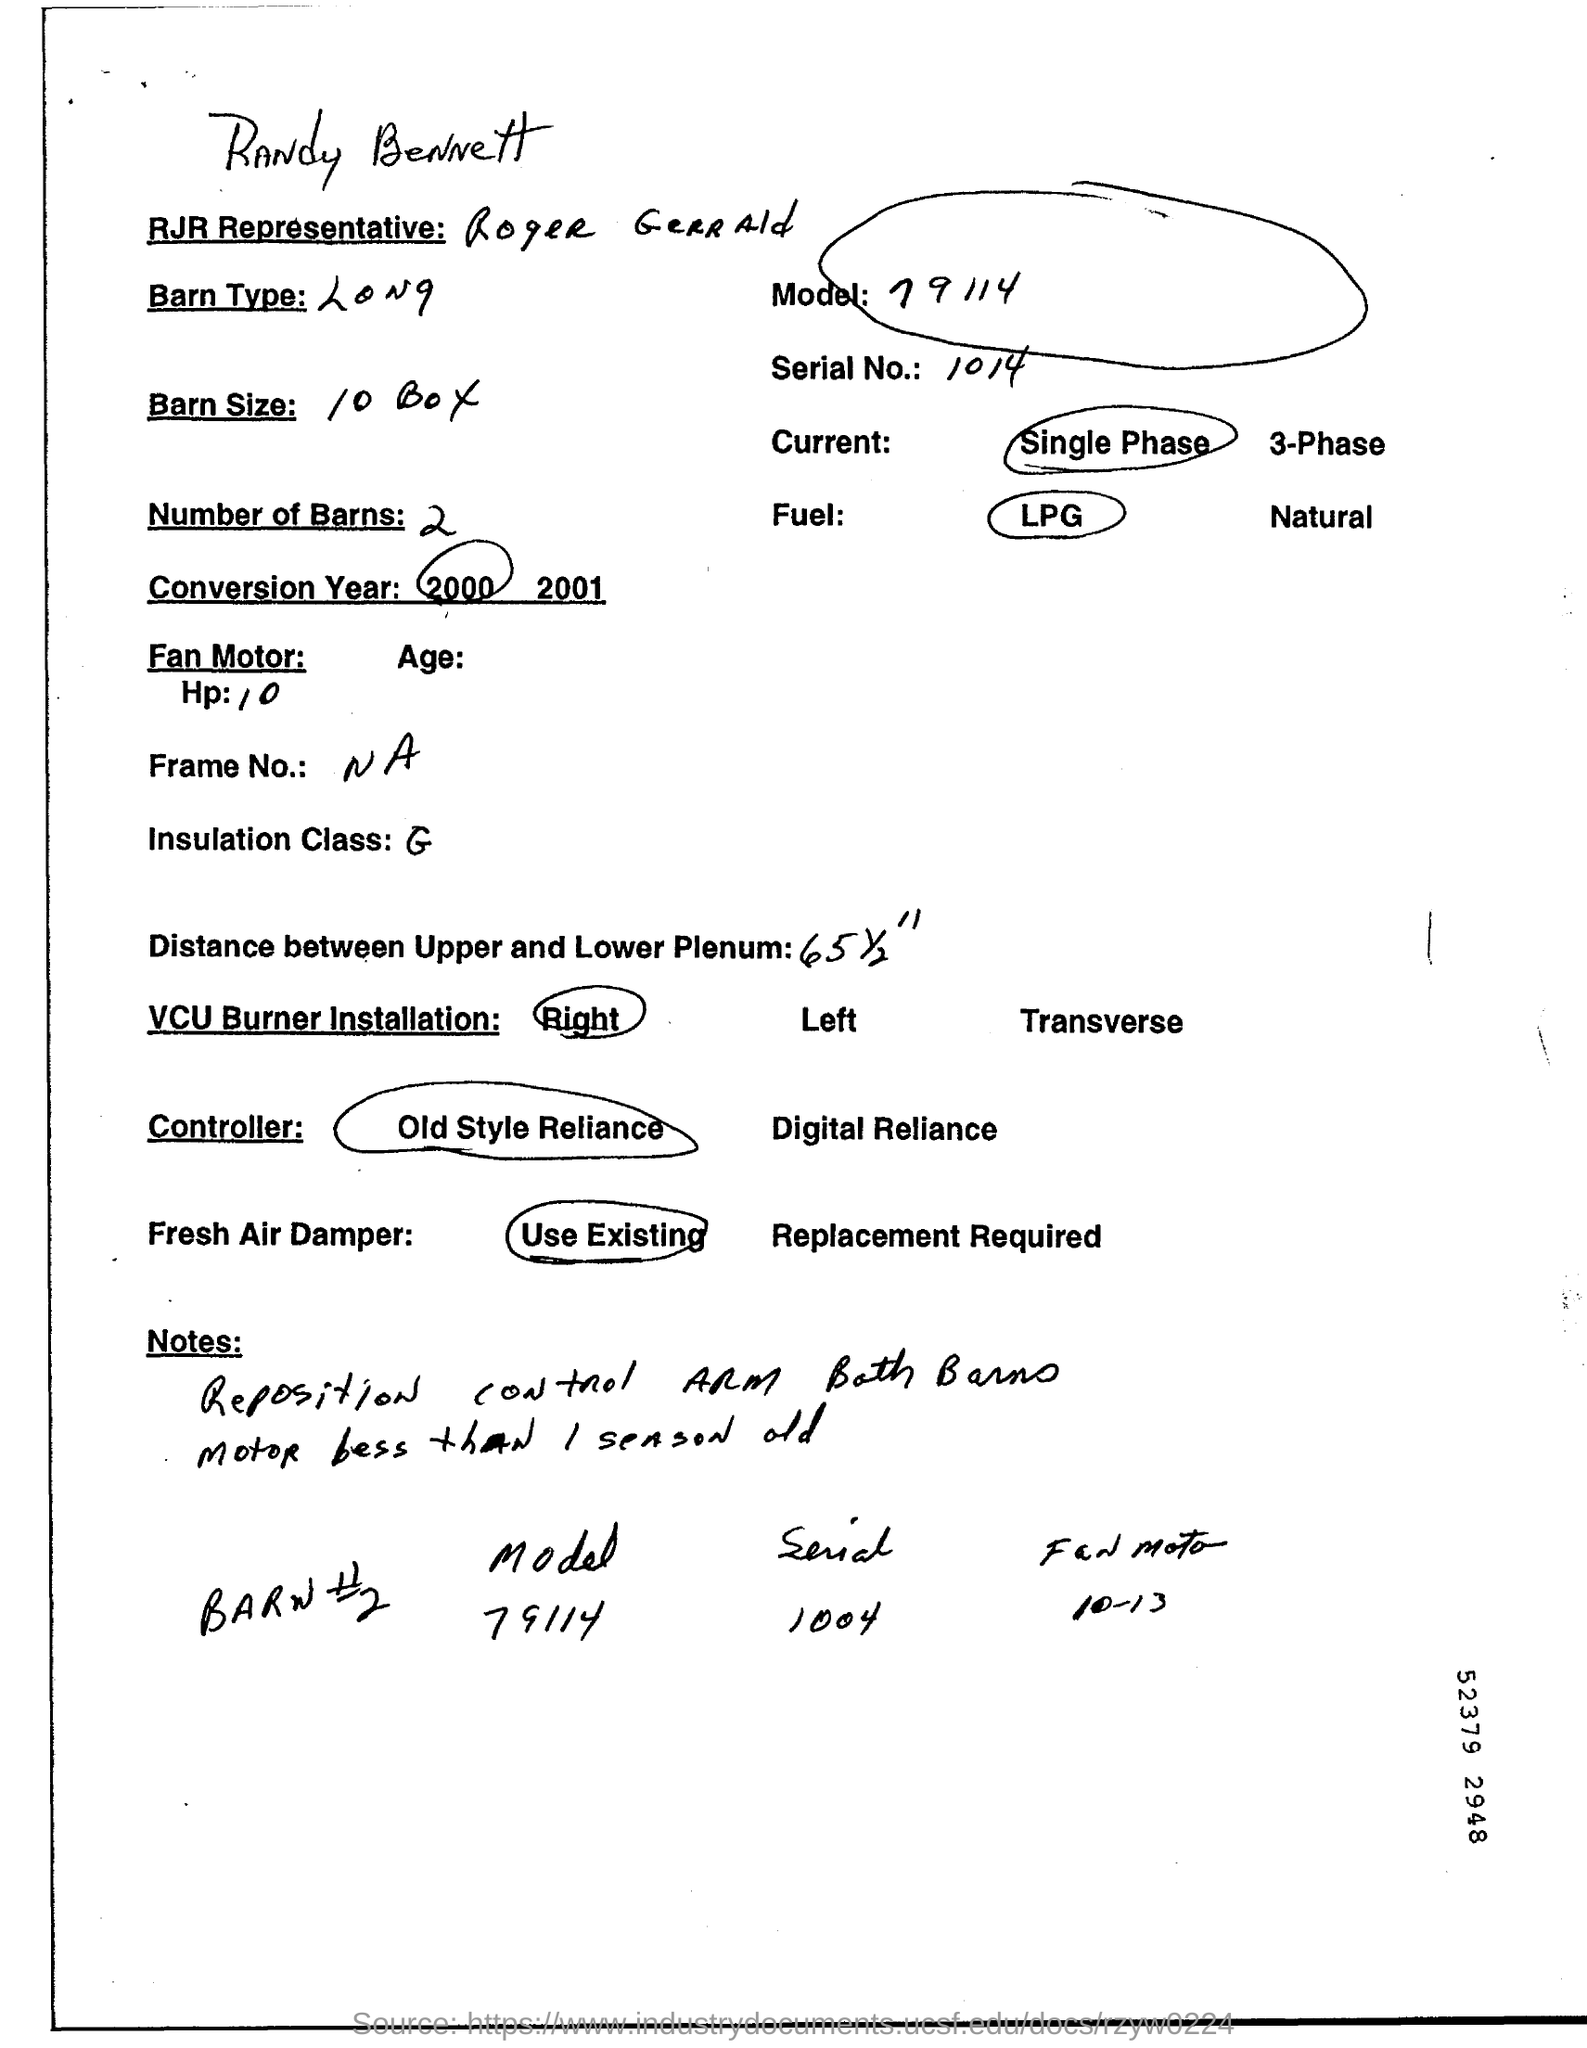What is the model number?
Offer a very short reply. 79114. How many number of barns are mentioned?
Keep it short and to the point. 2. Which type of fuel is circled?
Ensure brevity in your answer.  Lpg. Which conversion year is circled?
Provide a succinct answer. 2000. 